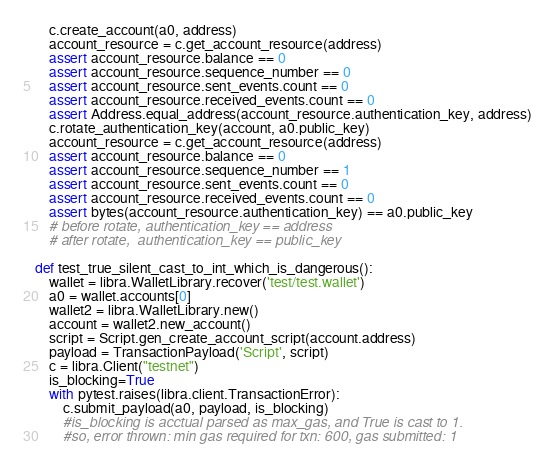<code> <loc_0><loc_0><loc_500><loc_500><_Python_>    c.create_account(a0, address)
    account_resource = c.get_account_resource(address)
    assert account_resource.balance == 0
    assert account_resource.sequence_number == 0
    assert account_resource.sent_events.count == 0
    assert account_resource.received_events.count == 0
    assert Address.equal_address(account_resource.authentication_key, address)
    c.rotate_authentication_key(account, a0.public_key)
    account_resource = c.get_account_resource(address)
    assert account_resource.balance == 0
    assert account_resource.sequence_number == 1
    assert account_resource.sent_events.count == 0
    assert account_resource.received_events.count == 0
    assert bytes(account_resource.authentication_key) == a0.public_key
    # before rotate, authentication_key == address
    # after rotate,  authentication_key == public_key

def test_true_silent_cast_to_int_which_is_dangerous():
    wallet = libra.WalletLibrary.recover('test/test.wallet')
    a0 = wallet.accounts[0]
    wallet2 = libra.WalletLibrary.new()
    account = wallet2.new_account()
    script = Script.gen_create_account_script(account.address)
    payload = TransactionPayload('Script', script)
    c = libra.Client("testnet")
    is_blocking=True
    with pytest.raises(libra.client.TransactionError):
        c.submit_payload(a0, payload, is_blocking)
        #is_blocking is acctual parsed as max_gas, and True is cast to 1.
        #so, error thrown: min gas required for txn: 600, gas submitted: 1



</code> 